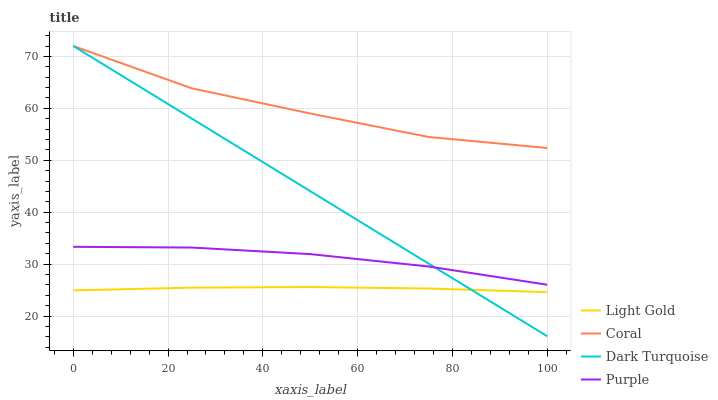Does Light Gold have the minimum area under the curve?
Answer yes or no. Yes. Does Coral have the maximum area under the curve?
Answer yes or no. Yes. Does Dark Turquoise have the minimum area under the curve?
Answer yes or no. No. Does Dark Turquoise have the maximum area under the curve?
Answer yes or no. No. Is Dark Turquoise the smoothest?
Answer yes or no. Yes. Is Coral the roughest?
Answer yes or no. Yes. Is Coral the smoothest?
Answer yes or no. No. Is Dark Turquoise the roughest?
Answer yes or no. No. Does Dark Turquoise have the lowest value?
Answer yes or no. Yes. Does Coral have the lowest value?
Answer yes or no. No. Does Coral have the highest value?
Answer yes or no. Yes. Does Light Gold have the highest value?
Answer yes or no. No. Is Light Gold less than Purple?
Answer yes or no. Yes. Is Coral greater than Purple?
Answer yes or no. Yes. Does Dark Turquoise intersect Purple?
Answer yes or no. Yes. Is Dark Turquoise less than Purple?
Answer yes or no. No. Is Dark Turquoise greater than Purple?
Answer yes or no. No. Does Light Gold intersect Purple?
Answer yes or no. No. 